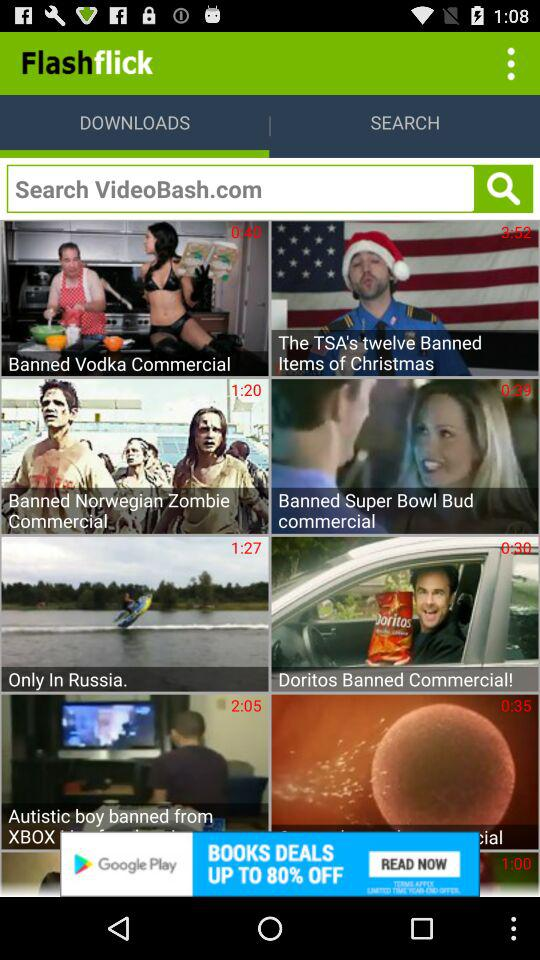What is the duration of "Only In Russia"? The duration is 1 minute and 27 seconds. 